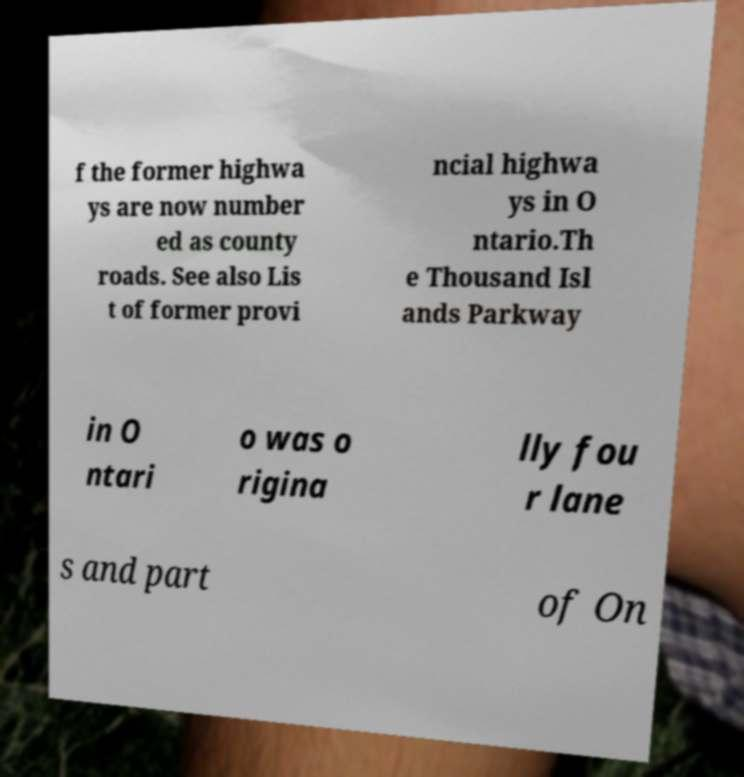Could you extract and type out the text from this image? f the former highwa ys are now number ed as county roads. See also Lis t of former provi ncial highwa ys in O ntario.Th e Thousand Isl ands Parkway in O ntari o was o rigina lly fou r lane s and part of On 